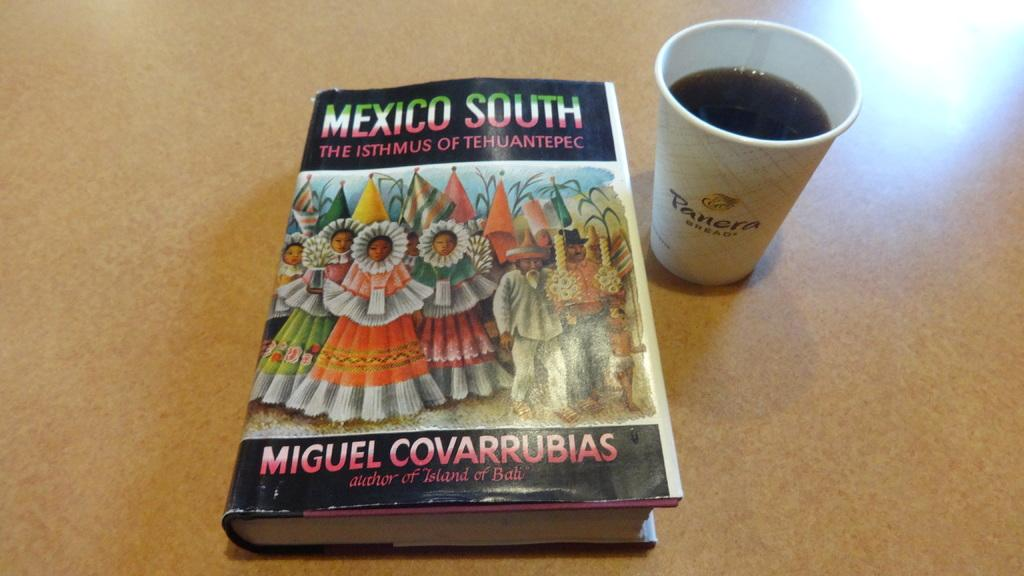<image>
Share a concise interpretation of the image provided. A book titled Mexico South sits next to a Panera Bread cup. 